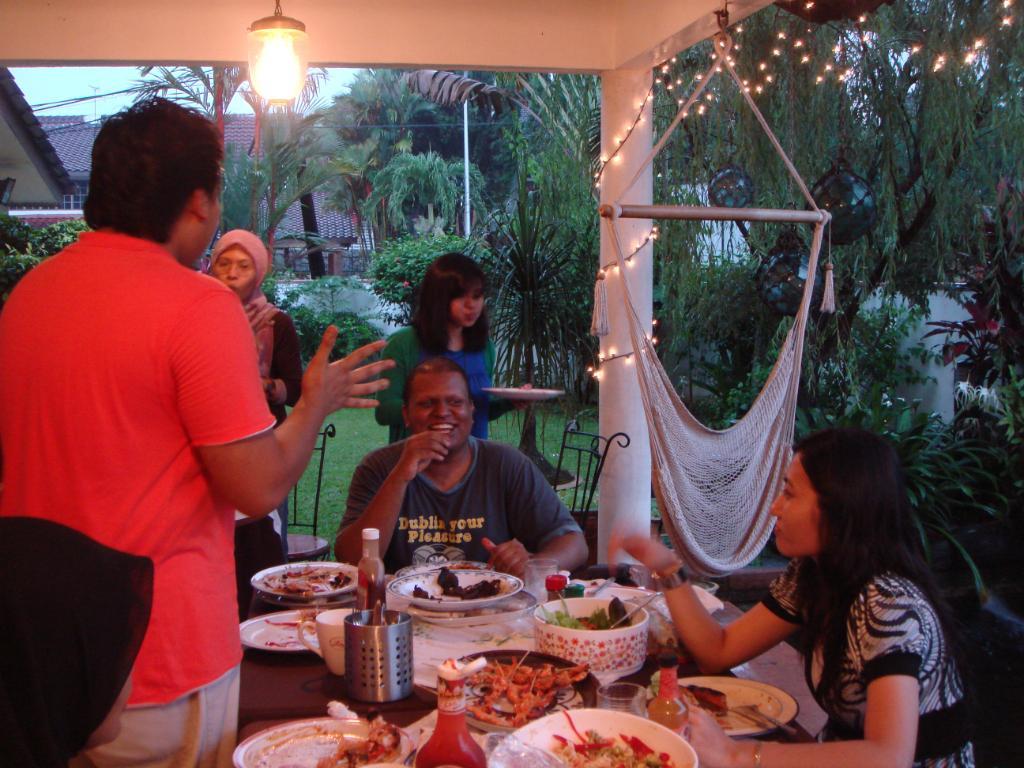Please provide a concise description of this image. An outdoor picture. These two persons are sitting on chairs, these three persons are standing. This woman is holding a plate. This man is smiling. On this table there are plates, bowl, bottles, glass and food. We can able to see trees, plants, grass and building. A light is attached to roof top. 